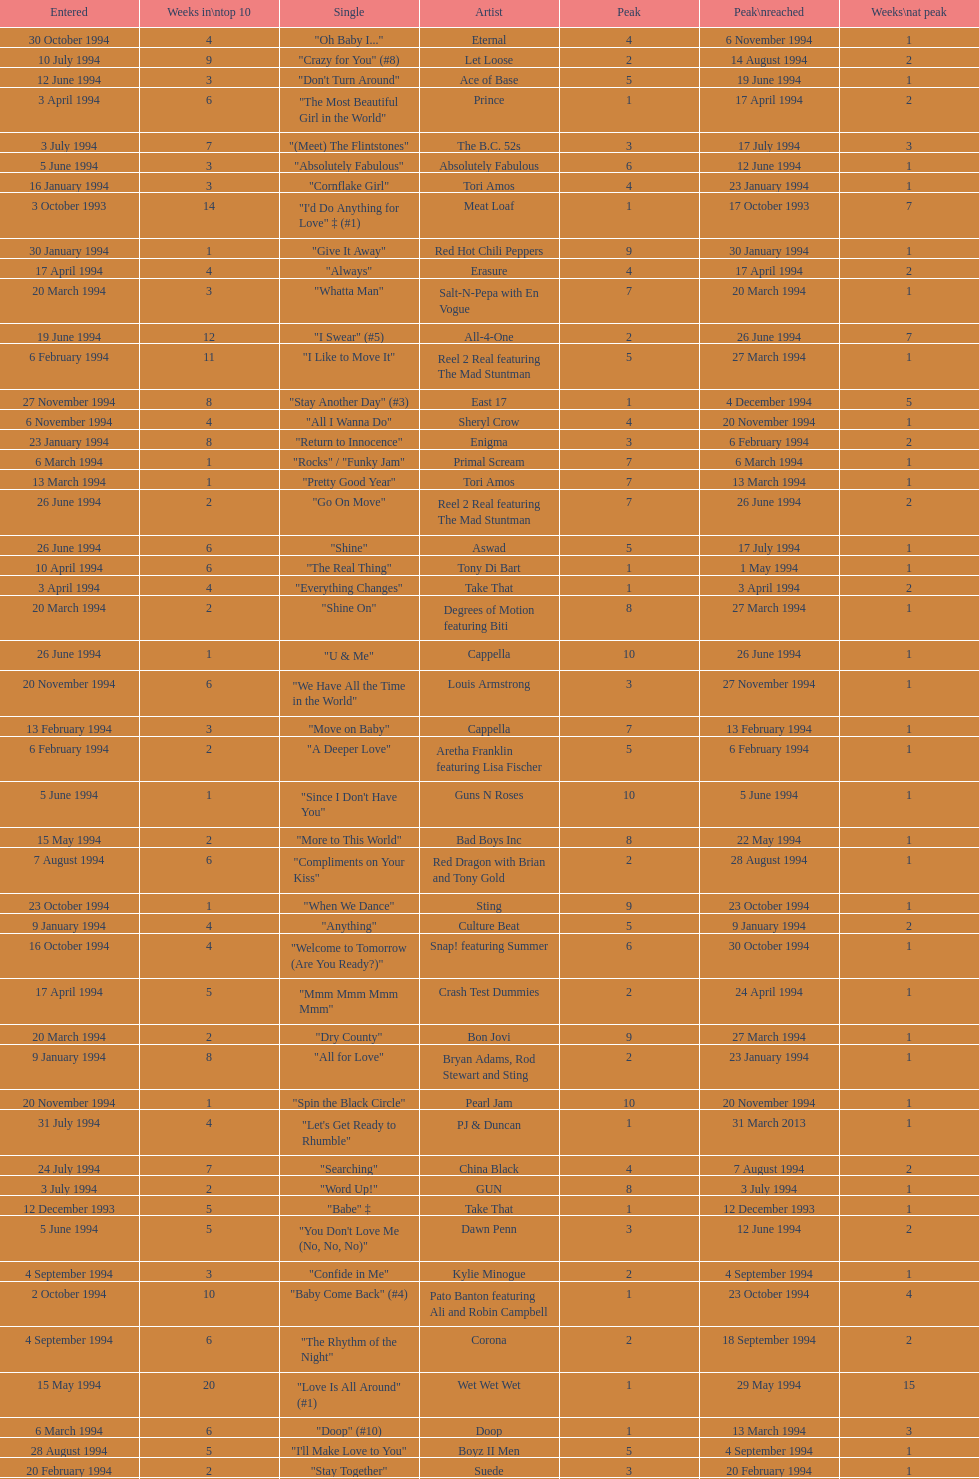Which artist only has its single entered on 2 january 1994? D:Ream. 